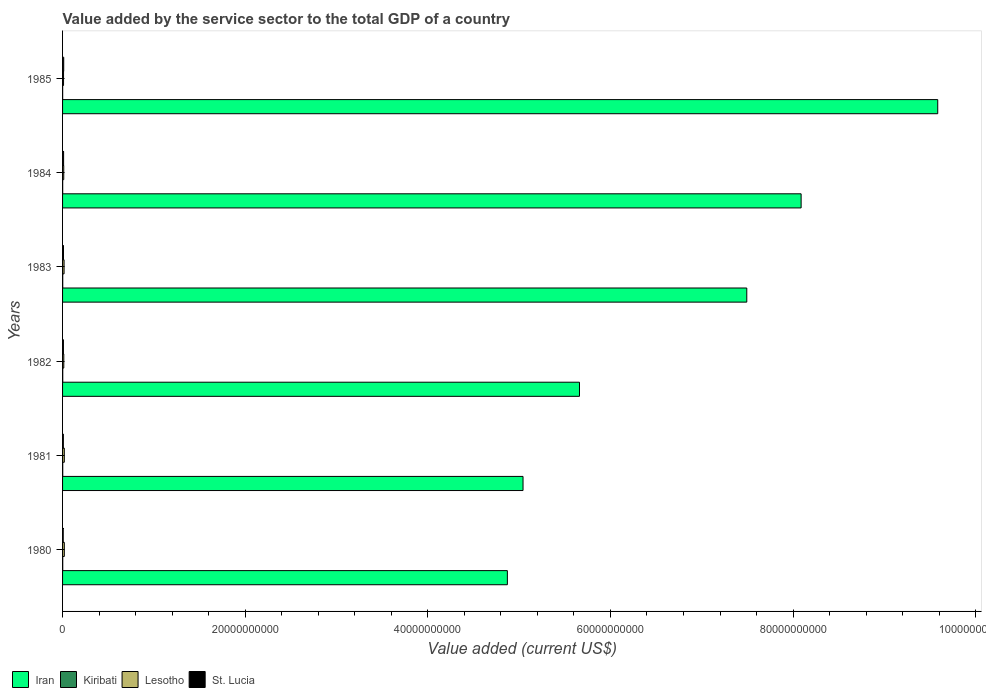How many different coloured bars are there?
Your answer should be very brief. 4. Are the number of bars per tick equal to the number of legend labels?
Offer a terse response. Yes. Are the number of bars on each tick of the Y-axis equal?
Your answer should be compact. Yes. How many bars are there on the 6th tick from the top?
Your answer should be compact. 4. How many bars are there on the 1st tick from the bottom?
Give a very brief answer. 4. What is the value added by the service sector to the total GDP in Kiribati in 1984?
Your answer should be compact. 1.28e+07. Across all years, what is the maximum value added by the service sector to the total GDP in Iran?
Offer a very short reply. 9.58e+1. Across all years, what is the minimum value added by the service sector to the total GDP in Iran?
Ensure brevity in your answer.  4.87e+1. What is the total value added by the service sector to the total GDP in Lesotho in the graph?
Ensure brevity in your answer.  9.23e+08. What is the difference between the value added by the service sector to the total GDP in Kiribati in 1982 and that in 1983?
Provide a succinct answer. 8.66e+05. What is the difference between the value added by the service sector to the total GDP in Lesotho in 1985 and the value added by the service sector to the total GDP in Iran in 1982?
Your answer should be very brief. -5.65e+1. What is the average value added by the service sector to the total GDP in Kiribati per year?
Offer a very short reply. 1.65e+07. In the year 1983, what is the difference between the value added by the service sector to the total GDP in Lesotho and value added by the service sector to the total GDP in Iran?
Provide a succinct answer. -7.48e+1. What is the ratio of the value added by the service sector to the total GDP in St. Lucia in 1981 to that in 1983?
Provide a short and direct response. 0.83. Is the difference between the value added by the service sector to the total GDP in Lesotho in 1982 and 1984 greater than the difference between the value added by the service sector to the total GDP in Iran in 1982 and 1984?
Your answer should be compact. Yes. What is the difference between the highest and the second highest value added by the service sector to the total GDP in Lesotho?
Offer a terse response. 7.68e+05. What is the difference between the highest and the lowest value added by the service sector to the total GDP in Iran?
Provide a short and direct response. 4.71e+1. In how many years, is the value added by the service sector to the total GDP in Kiribati greater than the average value added by the service sector to the total GDP in Kiribati taken over all years?
Give a very brief answer. 4. Is it the case that in every year, the sum of the value added by the service sector to the total GDP in Kiribati and value added by the service sector to the total GDP in Lesotho is greater than the sum of value added by the service sector to the total GDP in Iran and value added by the service sector to the total GDP in St. Lucia?
Offer a very short reply. No. What does the 2nd bar from the top in 1981 represents?
Your answer should be compact. Lesotho. What does the 2nd bar from the bottom in 1984 represents?
Your response must be concise. Kiribati. Is it the case that in every year, the sum of the value added by the service sector to the total GDP in Kiribati and value added by the service sector to the total GDP in Iran is greater than the value added by the service sector to the total GDP in St. Lucia?
Your response must be concise. Yes. How many bars are there?
Your answer should be compact. 24. Are all the bars in the graph horizontal?
Your answer should be compact. Yes. Are the values on the major ticks of X-axis written in scientific E-notation?
Provide a succinct answer. No. Does the graph contain grids?
Provide a succinct answer. No. How many legend labels are there?
Your response must be concise. 4. What is the title of the graph?
Keep it short and to the point. Value added by the service sector to the total GDP of a country. What is the label or title of the X-axis?
Give a very brief answer. Value added (current US$). What is the Value added (current US$) in Iran in 1980?
Keep it short and to the point. 4.87e+1. What is the Value added (current US$) of Kiribati in 1980?
Make the answer very short. 1.87e+07. What is the Value added (current US$) in Lesotho in 1980?
Make the answer very short. 1.92e+08. What is the Value added (current US$) of St. Lucia in 1980?
Offer a very short reply. 7.13e+07. What is the Value added (current US$) in Iran in 1981?
Your answer should be compact. 5.04e+1. What is the Value added (current US$) in Kiribati in 1981?
Ensure brevity in your answer.  1.85e+07. What is the Value added (current US$) of Lesotho in 1981?
Your answer should be very brief. 1.91e+08. What is the Value added (current US$) in St. Lucia in 1981?
Give a very brief answer. 8.51e+07. What is the Value added (current US$) of Iran in 1982?
Keep it short and to the point. 5.66e+1. What is the Value added (current US$) of Kiribati in 1982?
Give a very brief answer. 1.95e+07. What is the Value added (current US$) in Lesotho in 1982?
Ensure brevity in your answer.  1.36e+08. What is the Value added (current US$) of St. Lucia in 1982?
Keep it short and to the point. 9.37e+07. What is the Value added (current US$) in Iran in 1983?
Your answer should be compact. 7.49e+1. What is the Value added (current US$) in Kiribati in 1983?
Provide a succinct answer. 1.86e+07. What is the Value added (current US$) of Lesotho in 1983?
Your answer should be very brief. 1.66e+08. What is the Value added (current US$) of St. Lucia in 1983?
Keep it short and to the point. 1.03e+08. What is the Value added (current US$) of Iran in 1984?
Offer a very short reply. 8.09e+1. What is the Value added (current US$) in Kiribati in 1984?
Your answer should be compact. 1.28e+07. What is the Value added (current US$) of Lesotho in 1984?
Make the answer very short. 1.30e+08. What is the Value added (current US$) in St. Lucia in 1984?
Offer a terse response. 1.14e+08. What is the Value added (current US$) in Iran in 1985?
Make the answer very short. 9.58e+1. What is the Value added (current US$) in Kiribati in 1985?
Provide a short and direct response. 1.07e+07. What is the Value added (current US$) of Lesotho in 1985?
Offer a very short reply. 1.07e+08. What is the Value added (current US$) of St. Lucia in 1985?
Your answer should be very brief. 1.26e+08. Across all years, what is the maximum Value added (current US$) of Iran?
Make the answer very short. 9.58e+1. Across all years, what is the maximum Value added (current US$) in Kiribati?
Ensure brevity in your answer.  1.95e+07. Across all years, what is the maximum Value added (current US$) in Lesotho?
Make the answer very short. 1.92e+08. Across all years, what is the maximum Value added (current US$) of St. Lucia?
Offer a terse response. 1.26e+08. Across all years, what is the minimum Value added (current US$) in Iran?
Give a very brief answer. 4.87e+1. Across all years, what is the minimum Value added (current US$) of Kiribati?
Make the answer very short. 1.07e+07. Across all years, what is the minimum Value added (current US$) in Lesotho?
Keep it short and to the point. 1.07e+08. Across all years, what is the minimum Value added (current US$) in St. Lucia?
Provide a succinct answer. 7.13e+07. What is the total Value added (current US$) in Iran in the graph?
Offer a very short reply. 4.07e+11. What is the total Value added (current US$) of Kiribati in the graph?
Provide a short and direct response. 9.89e+07. What is the total Value added (current US$) of Lesotho in the graph?
Give a very brief answer. 9.23e+08. What is the total Value added (current US$) of St. Lucia in the graph?
Offer a very short reply. 5.93e+08. What is the difference between the Value added (current US$) of Iran in 1980 and that in 1981?
Your answer should be very brief. -1.72e+09. What is the difference between the Value added (current US$) of Kiribati in 1980 and that in 1981?
Your response must be concise. 1.97e+05. What is the difference between the Value added (current US$) of Lesotho in 1980 and that in 1981?
Ensure brevity in your answer.  7.68e+05. What is the difference between the Value added (current US$) in St. Lucia in 1980 and that in 1981?
Provide a succinct answer. -1.37e+07. What is the difference between the Value added (current US$) in Iran in 1980 and that in 1982?
Your answer should be very brief. -7.90e+09. What is the difference between the Value added (current US$) in Kiribati in 1980 and that in 1982?
Offer a terse response. -7.15e+05. What is the difference between the Value added (current US$) of Lesotho in 1980 and that in 1982?
Keep it short and to the point. 5.66e+07. What is the difference between the Value added (current US$) in St. Lucia in 1980 and that in 1982?
Your answer should be compact. -2.24e+07. What is the difference between the Value added (current US$) in Iran in 1980 and that in 1983?
Make the answer very short. -2.62e+1. What is the difference between the Value added (current US$) of Kiribati in 1980 and that in 1983?
Your answer should be very brief. 1.51e+05. What is the difference between the Value added (current US$) of Lesotho in 1980 and that in 1983?
Your response must be concise. 2.58e+07. What is the difference between the Value added (current US$) in St. Lucia in 1980 and that in 1983?
Your answer should be very brief. -3.17e+07. What is the difference between the Value added (current US$) in Iran in 1980 and that in 1984?
Ensure brevity in your answer.  -3.22e+1. What is the difference between the Value added (current US$) in Kiribati in 1980 and that in 1984?
Give a very brief answer. 5.90e+06. What is the difference between the Value added (current US$) of Lesotho in 1980 and that in 1984?
Your answer should be very brief. 6.21e+07. What is the difference between the Value added (current US$) in St. Lucia in 1980 and that in 1984?
Keep it short and to the point. -4.26e+07. What is the difference between the Value added (current US$) of Iran in 1980 and that in 1985?
Make the answer very short. -4.71e+1. What is the difference between the Value added (current US$) of Kiribati in 1980 and that in 1985?
Provide a succinct answer. 8.03e+06. What is the difference between the Value added (current US$) in Lesotho in 1980 and that in 1985?
Your response must be concise. 8.54e+07. What is the difference between the Value added (current US$) of St. Lucia in 1980 and that in 1985?
Make the answer very short. -5.46e+07. What is the difference between the Value added (current US$) in Iran in 1981 and that in 1982?
Your answer should be very brief. -6.18e+09. What is the difference between the Value added (current US$) in Kiribati in 1981 and that in 1982?
Your answer should be compact. -9.12e+05. What is the difference between the Value added (current US$) of Lesotho in 1981 and that in 1982?
Provide a short and direct response. 5.58e+07. What is the difference between the Value added (current US$) in St. Lucia in 1981 and that in 1982?
Your response must be concise. -8.67e+06. What is the difference between the Value added (current US$) of Iran in 1981 and that in 1983?
Your answer should be very brief. -2.45e+1. What is the difference between the Value added (current US$) of Kiribati in 1981 and that in 1983?
Provide a succinct answer. -4.57e+04. What is the difference between the Value added (current US$) of Lesotho in 1981 and that in 1983?
Provide a short and direct response. 2.50e+07. What is the difference between the Value added (current US$) in St. Lucia in 1981 and that in 1983?
Your response must be concise. -1.80e+07. What is the difference between the Value added (current US$) in Iran in 1981 and that in 1984?
Offer a terse response. -3.05e+1. What is the difference between the Value added (current US$) in Kiribati in 1981 and that in 1984?
Ensure brevity in your answer.  5.70e+06. What is the difference between the Value added (current US$) in Lesotho in 1981 and that in 1984?
Provide a succinct answer. 6.14e+07. What is the difference between the Value added (current US$) in St. Lucia in 1981 and that in 1984?
Your answer should be very brief. -2.89e+07. What is the difference between the Value added (current US$) in Iran in 1981 and that in 1985?
Your response must be concise. -4.54e+1. What is the difference between the Value added (current US$) in Kiribati in 1981 and that in 1985?
Keep it short and to the point. 7.83e+06. What is the difference between the Value added (current US$) in Lesotho in 1981 and that in 1985?
Offer a terse response. 8.46e+07. What is the difference between the Value added (current US$) in St. Lucia in 1981 and that in 1985?
Make the answer very short. -4.09e+07. What is the difference between the Value added (current US$) in Iran in 1982 and that in 1983?
Your response must be concise. -1.83e+1. What is the difference between the Value added (current US$) in Kiribati in 1982 and that in 1983?
Provide a short and direct response. 8.66e+05. What is the difference between the Value added (current US$) in Lesotho in 1982 and that in 1983?
Your answer should be compact. -3.08e+07. What is the difference between the Value added (current US$) of St. Lucia in 1982 and that in 1983?
Offer a very short reply. -9.30e+06. What is the difference between the Value added (current US$) of Iran in 1982 and that in 1984?
Your response must be concise. -2.43e+1. What is the difference between the Value added (current US$) of Kiribati in 1982 and that in 1984?
Provide a short and direct response. 6.61e+06. What is the difference between the Value added (current US$) of Lesotho in 1982 and that in 1984?
Your answer should be compact. 5.53e+06. What is the difference between the Value added (current US$) of St. Lucia in 1982 and that in 1984?
Ensure brevity in your answer.  -2.02e+07. What is the difference between the Value added (current US$) in Iran in 1982 and that in 1985?
Offer a very short reply. -3.92e+1. What is the difference between the Value added (current US$) of Kiribati in 1982 and that in 1985?
Keep it short and to the point. 8.74e+06. What is the difference between the Value added (current US$) in Lesotho in 1982 and that in 1985?
Provide a succinct answer. 2.88e+07. What is the difference between the Value added (current US$) in St. Lucia in 1982 and that in 1985?
Make the answer very short. -3.22e+07. What is the difference between the Value added (current US$) of Iran in 1983 and that in 1984?
Your answer should be compact. -5.95e+09. What is the difference between the Value added (current US$) of Kiribati in 1983 and that in 1984?
Offer a very short reply. 5.74e+06. What is the difference between the Value added (current US$) in Lesotho in 1983 and that in 1984?
Make the answer very short. 3.64e+07. What is the difference between the Value added (current US$) in St. Lucia in 1983 and that in 1984?
Your response must be concise. -1.09e+07. What is the difference between the Value added (current US$) of Iran in 1983 and that in 1985?
Your answer should be very brief. -2.09e+1. What is the difference between the Value added (current US$) in Kiribati in 1983 and that in 1985?
Your answer should be very brief. 7.88e+06. What is the difference between the Value added (current US$) of Lesotho in 1983 and that in 1985?
Offer a terse response. 5.96e+07. What is the difference between the Value added (current US$) in St. Lucia in 1983 and that in 1985?
Your response must be concise. -2.29e+07. What is the difference between the Value added (current US$) in Iran in 1984 and that in 1985?
Offer a terse response. -1.50e+1. What is the difference between the Value added (current US$) of Kiribati in 1984 and that in 1985?
Provide a succinct answer. 2.13e+06. What is the difference between the Value added (current US$) of Lesotho in 1984 and that in 1985?
Make the answer very short. 2.33e+07. What is the difference between the Value added (current US$) of St. Lucia in 1984 and that in 1985?
Your response must be concise. -1.20e+07. What is the difference between the Value added (current US$) of Iran in 1980 and the Value added (current US$) of Kiribati in 1981?
Offer a very short reply. 4.87e+1. What is the difference between the Value added (current US$) of Iran in 1980 and the Value added (current US$) of Lesotho in 1981?
Give a very brief answer. 4.85e+1. What is the difference between the Value added (current US$) of Iran in 1980 and the Value added (current US$) of St. Lucia in 1981?
Your answer should be compact. 4.86e+1. What is the difference between the Value added (current US$) of Kiribati in 1980 and the Value added (current US$) of Lesotho in 1981?
Your answer should be compact. -1.73e+08. What is the difference between the Value added (current US$) of Kiribati in 1980 and the Value added (current US$) of St. Lucia in 1981?
Ensure brevity in your answer.  -6.63e+07. What is the difference between the Value added (current US$) in Lesotho in 1980 and the Value added (current US$) in St. Lucia in 1981?
Offer a terse response. 1.07e+08. What is the difference between the Value added (current US$) in Iran in 1980 and the Value added (current US$) in Kiribati in 1982?
Provide a succinct answer. 4.87e+1. What is the difference between the Value added (current US$) in Iran in 1980 and the Value added (current US$) in Lesotho in 1982?
Your answer should be very brief. 4.86e+1. What is the difference between the Value added (current US$) of Iran in 1980 and the Value added (current US$) of St. Lucia in 1982?
Your answer should be compact. 4.86e+1. What is the difference between the Value added (current US$) in Kiribati in 1980 and the Value added (current US$) in Lesotho in 1982?
Your response must be concise. -1.17e+08. What is the difference between the Value added (current US$) of Kiribati in 1980 and the Value added (current US$) of St. Lucia in 1982?
Make the answer very short. -7.50e+07. What is the difference between the Value added (current US$) of Lesotho in 1980 and the Value added (current US$) of St. Lucia in 1982?
Your answer should be very brief. 9.85e+07. What is the difference between the Value added (current US$) in Iran in 1980 and the Value added (current US$) in Kiribati in 1983?
Offer a very short reply. 4.87e+1. What is the difference between the Value added (current US$) in Iran in 1980 and the Value added (current US$) in Lesotho in 1983?
Your response must be concise. 4.85e+1. What is the difference between the Value added (current US$) of Iran in 1980 and the Value added (current US$) of St. Lucia in 1983?
Your answer should be compact. 4.86e+1. What is the difference between the Value added (current US$) of Kiribati in 1980 and the Value added (current US$) of Lesotho in 1983?
Offer a very short reply. -1.48e+08. What is the difference between the Value added (current US$) of Kiribati in 1980 and the Value added (current US$) of St. Lucia in 1983?
Offer a terse response. -8.43e+07. What is the difference between the Value added (current US$) in Lesotho in 1980 and the Value added (current US$) in St. Lucia in 1983?
Provide a short and direct response. 8.92e+07. What is the difference between the Value added (current US$) in Iran in 1980 and the Value added (current US$) in Kiribati in 1984?
Offer a terse response. 4.87e+1. What is the difference between the Value added (current US$) in Iran in 1980 and the Value added (current US$) in Lesotho in 1984?
Keep it short and to the point. 4.86e+1. What is the difference between the Value added (current US$) in Iran in 1980 and the Value added (current US$) in St. Lucia in 1984?
Provide a short and direct response. 4.86e+1. What is the difference between the Value added (current US$) in Kiribati in 1980 and the Value added (current US$) in Lesotho in 1984?
Provide a short and direct response. -1.11e+08. What is the difference between the Value added (current US$) of Kiribati in 1980 and the Value added (current US$) of St. Lucia in 1984?
Your answer should be compact. -9.52e+07. What is the difference between the Value added (current US$) of Lesotho in 1980 and the Value added (current US$) of St. Lucia in 1984?
Your answer should be very brief. 7.82e+07. What is the difference between the Value added (current US$) in Iran in 1980 and the Value added (current US$) in Kiribati in 1985?
Keep it short and to the point. 4.87e+1. What is the difference between the Value added (current US$) in Iran in 1980 and the Value added (current US$) in Lesotho in 1985?
Your response must be concise. 4.86e+1. What is the difference between the Value added (current US$) of Iran in 1980 and the Value added (current US$) of St. Lucia in 1985?
Your response must be concise. 4.86e+1. What is the difference between the Value added (current US$) of Kiribati in 1980 and the Value added (current US$) of Lesotho in 1985?
Offer a very short reply. -8.81e+07. What is the difference between the Value added (current US$) in Kiribati in 1980 and the Value added (current US$) in St. Lucia in 1985?
Give a very brief answer. -1.07e+08. What is the difference between the Value added (current US$) in Lesotho in 1980 and the Value added (current US$) in St. Lucia in 1985?
Your answer should be very brief. 6.62e+07. What is the difference between the Value added (current US$) in Iran in 1981 and the Value added (current US$) in Kiribati in 1982?
Provide a succinct answer. 5.04e+1. What is the difference between the Value added (current US$) in Iran in 1981 and the Value added (current US$) in Lesotho in 1982?
Ensure brevity in your answer.  5.03e+1. What is the difference between the Value added (current US$) in Iran in 1981 and the Value added (current US$) in St. Lucia in 1982?
Give a very brief answer. 5.03e+1. What is the difference between the Value added (current US$) in Kiribati in 1981 and the Value added (current US$) in Lesotho in 1982?
Offer a terse response. -1.17e+08. What is the difference between the Value added (current US$) in Kiribati in 1981 and the Value added (current US$) in St. Lucia in 1982?
Provide a short and direct response. -7.52e+07. What is the difference between the Value added (current US$) of Lesotho in 1981 and the Value added (current US$) of St. Lucia in 1982?
Your answer should be compact. 9.77e+07. What is the difference between the Value added (current US$) in Iran in 1981 and the Value added (current US$) in Kiribati in 1983?
Make the answer very short. 5.04e+1. What is the difference between the Value added (current US$) in Iran in 1981 and the Value added (current US$) in Lesotho in 1983?
Your answer should be very brief. 5.03e+1. What is the difference between the Value added (current US$) in Iran in 1981 and the Value added (current US$) in St. Lucia in 1983?
Provide a short and direct response. 5.03e+1. What is the difference between the Value added (current US$) of Kiribati in 1981 and the Value added (current US$) of Lesotho in 1983?
Give a very brief answer. -1.48e+08. What is the difference between the Value added (current US$) in Kiribati in 1981 and the Value added (current US$) in St. Lucia in 1983?
Your answer should be compact. -8.45e+07. What is the difference between the Value added (current US$) of Lesotho in 1981 and the Value added (current US$) of St. Lucia in 1983?
Ensure brevity in your answer.  8.84e+07. What is the difference between the Value added (current US$) in Iran in 1981 and the Value added (current US$) in Kiribati in 1984?
Your response must be concise. 5.04e+1. What is the difference between the Value added (current US$) in Iran in 1981 and the Value added (current US$) in Lesotho in 1984?
Provide a succinct answer. 5.03e+1. What is the difference between the Value added (current US$) of Iran in 1981 and the Value added (current US$) of St. Lucia in 1984?
Make the answer very short. 5.03e+1. What is the difference between the Value added (current US$) of Kiribati in 1981 and the Value added (current US$) of Lesotho in 1984?
Ensure brevity in your answer.  -1.12e+08. What is the difference between the Value added (current US$) in Kiribati in 1981 and the Value added (current US$) in St. Lucia in 1984?
Ensure brevity in your answer.  -9.54e+07. What is the difference between the Value added (current US$) in Lesotho in 1981 and the Value added (current US$) in St. Lucia in 1984?
Your answer should be very brief. 7.75e+07. What is the difference between the Value added (current US$) in Iran in 1981 and the Value added (current US$) in Kiribati in 1985?
Make the answer very short. 5.04e+1. What is the difference between the Value added (current US$) of Iran in 1981 and the Value added (current US$) of Lesotho in 1985?
Your response must be concise. 5.03e+1. What is the difference between the Value added (current US$) in Iran in 1981 and the Value added (current US$) in St. Lucia in 1985?
Provide a short and direct response. 5.03e+1. What is the difference between the Value added (current US$) in Kiribati in 1981 and the Value added (current US$) in Lesotho in 1985?
Keep it short and to the point. -8.83e+07. What is the difference between the Value added (current US$) in Kiribati in 1981 and the Value added (current US$) in St. Lucia in 1985?
Give a very brief answer. -1.07e+08. What is the difference between the Value added (current US$) of Lesotho in 1981 and the Value added (current US$) of St. Lucia in 1985?
Offer a very short reply. 6.55e+07. What is the difference between the Value added (current US$) in Iran in 1982 and the Value added (current US$) in Kiribati in 1983?
Provide a succinct answer. 5.66e+1. What is the difference between the Value added (current US$) of Iran in 1982 and the Value added (current US$) of Lesotho in 1983?
Your answer should be compact. 5.64e+1. What is the difference between the Value added (current US$) of Iran in 1982 and the Value added (current US$) of St. Lucia in 1983?
Provide a succinct answer. 5.65e+1. What is the difference between the Value added (current US$) in Kiribati in 1982 and the Value added (current US$) in Lesotho in 1983?
Your answer should be very brief. -1.47e+08. What is the difference between the Value added (current US$) in Kiribati in 1982 and the Value added (current US$) in St. Lucia in 1983?
Offer a very short reply. -8.36e+07. What is the difference between the Value added (current US$) of Lesotho in 1982 and the Value added (current US$) of St. Lucia in 1983?
Your answer should be compact. 3.26e+07. What is the difference between the Value added (current US$) of Iran in 1982 and the Value added (current US$) of Kiribati in 1984?
Provide a succinct answer. 5.66e+1. What is the difference between the Value added (current US$) in Iran in 1982 and the Value added (current US$) in Lesotho in 1984?
Your answer should be compact. 5.65e+1. What is the difference between the Value added (current US$) of Iran in 1982 and the Value added (current US$) of St. Lucia in 1984?
Your response must be concise. 5.65e+1. What is the difference between the Value added (current US$) of Kiribati in 1982 and the Value added (current US$) of Lesotho in 1984?
Provide a short and direct response. -1.11e+08. What is the difference between the Value added (current US$) of Kiribati in 1982 and the Value added (current US$) of St. Lucia in 1984?
Provide a succinct answer. -9.45e+07. What is the difference between the Value added (current US$) of Lesotho in 1982 and the Value added (current US$) of St. Lucia in 1984?
Your answer should be compact. 2.16e+07. What is the difference between the Value added (current US$) in Iran in 1982 and the Value added (current US$) in Kiribati in 1985?
Your response must be concise. 5.66e+1. What is the difference between the Value added (current US$) of Iran in 1982 and the Value added (current US$) of Lesotho in 1985?
Keep it short and to the point. 5.65e+1. What is the difference between the Value added (current US$) of Iran in 1982 and the Value added (current US$) of St. Lucia in 1985?
Offer a very short reply. 5.65e+1. What is the difference between the Value added (current US$) in Kiribati in 1982 and the Value added (current US$) in Lesotho in 1985?
Your response must be concise. -8.74e+07. What is the difference between the Value added (current US$) of Kiribati in 1982 and the Value added (current US$) of St. Lucia in 1985?
Provide a short and direct response. -1.07e+08. What is the difference between the Value added (current US$) in Lesotho in 1982 and the Value added (current US$) in St. Lucia in 1985?
Provide a short and direct response. 9.62e+06. What is the difference between the Value added (current US$) in Iran in 1983 and the Value added (current US$) in Kiribati in 1984?
Give a very brief answer. 7.49e+1. What is the difference between the Value added (current US$) of Iran in 1983 and the Value added (current US$) of Lesotho in 1984?
Offer a terse response. 7.48e+1. What is the difference between the Value added (current US$) in Iran in 1983 and the Value added (current US$) in St. Lucia in 1984?
Offer a terse response. 7.48e+1. What is the difference between the Value added (current US$) of Kiribati in 1983 and the Value added (current US$) of Lesotho in 1984?
Provide a short and direct response. -1.11e+08. What is the difference between the Value added (current US$) of Kiribati in 1983 and the Value added (current US$) of St. Lucia in 1984?
Give a very brief answer. -9.54e+07. What is the difference between the Value added (current US$) of Lesotho in 1983 and the Value added (current US$) of St. Lucia in 1984?
Ensure brevity in your answer.  5.25e+07. What is the difference between the Value added (current US$) in Iran in 1983 and the Value added (current US$) in Kiribati in 1985?
Offer a very short reply. 7.49e+1. What is the difference between the Value added (current US$) of Iran in 1983 and the Value added (current US$) of Lesotho in 1985?
Ensure brevity in your answer.  7.48e+1. What is the difference between the Value added (current US$) of Iran in 1983 and the Value added (current US$) of St. Lucia in 1985?
Your response must be concise. 7.48e+1. What is the difference between the Value added (current US$) of Kiribati in 1983 and the Value added (current US$) of Lesotho in 1985?
Ensure brevity in your answer.  -8.82e+07. What is the difference between the Value added (current US$) of Kiribati in 1983 and the Value added (current US$) of St. Lucia in 1985?
Your answer should be very brief. -1.07e+08. What is the difference between the Value added (current US$) of Lesotho in 1983 and the Value added (current US$) of St. Lucia in 1985?
Your answer should be very brief. 4.05e+07. What is the difference between the Value added (current US$) in Iran in 1984 and the Value added (current US$) in Kiribati in 1985?
Provide a succinct answer. 8.09e+1. What is the difference between the Value added (current US$) of Iran in 1984 and the Value added (current US$) of Lesotho in 1985?
Your answer should be very brief. 8.08e+1. What is the difference between the Value added (current US$) in Iran in 1984 and the Value added (current US$) in St. Lucia in 1985?
Ensure brevity in your answer.  8.08e+1. What is the difference between the Value added (current US$) in Kiribati in 1984 and the Value added (current US$) in Lesotho in 1985?
Offer a very short reply. -9.40e+07. What is the difference between the Value added (current US$) in Kiribati in 1984 and the Value added (current US$) in St. Lucia in 1985?
Offer a terse response. -1.13e+08. What is the difference between the Value added (current US$) in Lesotho in 1984 and the Value added (current US$) in St. Lucia in 1985?
Provide a succinct answer. 4.09e+06. What is the average Value added (current US$) of Iran per year?
Your answer should be compact. 6.79e+1. What is the average Value added (current US$) of Kiribati per year?
Provide a succinct answer. 1.65e+07. What is the average Value added (current US$) of Lesotho per year?
Provide a succinct answer. 1.54e+08. What is the average Value added (current US$) in St. Lucia per year?
Ensure brevity in your answer.  9.89e+07. In the year 1980, what is the difference between the Value added (current US$) of Iran and Value added (current US$) of Kiribati?
Provide a succinct answer. 4.87e+1. In the year 1980, what is the difference between the Value added (current US$) in Iran and Value added (current US$) in Lesotho?
Your response must be concise. 4.85e+1. In the year 1980, what is the difference between the Value added (current US$) of Iran and Value added (current US$) of St. Lucia?
Make the answer very short. 4.86e+1. In the year 1980, what is the difference between the Value added (current US$) of Kiribati and Value added (current US$) of Lesotho?
Your response must be concise. -1.73e+08. In the year 1980, what is the difference between the Value added (current US$) of Kiribati and Value added (current US$) of St. Lucia?
Keep it short and to the point. -5.26e+07. In the year 1980, what is the difference between the Value added (current US$) in Lesotho and Value added (current US$) in St. Lucia?
Offer a very short reply. 1.21e+08. In the year 1981, what is the difference between the Value added (current US$) in Iran and Value added (current US$) in Kiribati?
Provide a succinct answer. 5.04e+1. In the year 1981, what is the difference between the Value added (current US$) in Iran and Value added (current US$) in Lesotho?
Your answer should be very brief. 5.02e+1. In the year 1981, what is the difference between the Value added (current US$) in Iran and Value added (current US$) in St. Lucia?
Your response must be concise. 5.03e+1. In the year 1981, what is the difference between the Value added (current US$) of Kiribati and Value added (current US$) of Lesotho?
Provide a succinct answer. -1.73e+08. In the year 1981, what is the difference between the Value added (current US$) in Kiribati and Value added (current US$) in St. Lucia?
Ensure brevity in your answer.  -6.65e+07. In the year 1981, what is the difference between the Value added (current US$) of Lesotho and Value added (current US$) of St. Lucia?
Give a very brief answer. 1.06e+08. In the year 1982, what is the difference between the Value added (current US$) of Iran and Value added (current US$) of Kiribati?
Offer a terse response. 5.66e+1. In the year 1982, what is the difference between the Value added (current US$) of Iran and Value added (current US$) of Lesotho?
Your answer should be compact. 5.65e+1. In the year 1982, what is the difference between the Value added (current US$) in Iran and Value added (current US$) in St. Lucia?
Make the answer very short. 5.65e+1. In the year 1982, what is the difference between the Value added (current US$) of Kiribati and Value added (current US$) of Lesotho?
Your answer should be compact. -1.16e+08. In the year 1982, what is the difference between the Value added (current US$) of Kiribati and Value added (current US$) of St. Lucia?
Provide a succinct answer. -7.43e+07. In the year 1982, what is the difference between the Value added (current US$) of Lesotho and Value added (current US$) of St. Lucia?
Ensure brevity in your answer.  4.19e+07. In the year 1983, what is the difference between the Value added (current US$) of Iran and Value added (current US$) of Kiribati?
Your answer should be compact. 7.49e+1. In the year 1983, what is the difference between the Value added (current US$) of Iran and Value added (current US$) of Lesotho?
Give a very brief answer. 7.48e+1. In the year 1983, what is the difference between the Value added (current US$) of Iran and Value added (current US$) of St. Lucia?
Offer a terse response. 7.48e+1. In the year 1983, what is the difference between the Value added (current US$) of Kiribati and Value added (current US$) of Lesotho?
Your answer should be very brief. -1.48e+08. In the year 1983, what is the difference between the Value added (current US$) in Kiribati and Value added (current US$) in St. Lucia?
Your answer should be very brief. -8.44e+07. In the year 1983, what is the difference between the Value added (current US$) of Lesotho and Value added (current US$) of St. Lucia?
Provide a short and direct response. 6.34e+07. In the year 1984, what is the difference between the Value added (current US$) in Iran and Value added (current US$) in Kiribati?
Your answer should be compact. 8.09e+1. In the year 1984, what is the difference between the Value added (current US$) in Iran and Value added (current US$) in Lesotho?
Ensure brevity in your answer.  8.08e+1. In the year 1984, what is the difference between the Value added (current US$) of Iran and Value added (current US$) of St. Lucia?
Your answer should be very brief. 8.08e+1. In the year 1984, what is the difference between the Value added (current US$) in Kiribati and Value added (current US$) in Lesotho?
Ensure brevity in your answer.  -1.17e+08. In the year 1984, what is the difference between the Value added (current US$) in Kiribati and Value added (current US$) in St. Lucia?
Offer a terse response. -1.01e+08. In the year 1984, what is the difference between the Value added (current US$) of Lesotho and Value added (current US$) of St. Lucia?
Your answer should be very brief. 1.61e+07. In the year 1985, what is the difference between the Value added (current US$) of Iran and Value added (current US$) of Kiribati?
Provide a succinct answer. 9.58e+1. In the year 1985, what is the difference between the Value added (current US$) in Iran and Value added (current US$) in Lesotho?
Your answer should be very brief. 9.57e+1. In the year 1985, what is the difference between the Value added (current US$) of Iran and Value added (current US$) of St. Lucia?
Offer a terse response. 9.57e+1. In the year 1985, what is the difference between the Value added (current US$) of Kiribati and Value added (current US$) of Lesotho?
Give a very brief answer. -9.61e+07. In the year 1985, what is the difference between the Value added (current US$) in Kiribati and Value added (current US$) in St. Lucia?
Provide a succinct answer. -1.15e+08. In the year 1985, what is the difference between the Value added (current US$) of Lesotho and Value added (current US$) of St. Lucia?
Your answer should be compact. -1.92e+07. What is the ratio of the Value added (current US$) of Kiribati in 1980 to that in 1981?
Offer a terse response. 1.01. What is the ratio of the Value added (current US$) in St. Lucia in 1980 to that in 1981?
Your answer should be very brief. 0.84. What is the ratio of the Value added (current US$) of Iran in 1980 to that in 1982?
Your answer should be very brief. 0.86. What is the ratio of the Value added (current US$) of Kiribati in 1980 to that in 1982?
Provide a succinct answer. 0.96. What is the ratio of the Value added (current US$) of Lesotho in 1980 to that in 1982?
Your answer should be compact. 1.42. What is the ratio of the Value added (current US$) in St. Lucia in 1980 to that in 1982?
Offer a terse response. 0.76. What is the ratio of the Value added (current US$) in Iran in 1980 to that in 1983?
Offer a terse response. 0.65. What is the ratio of the Value added (current US$) in Kiribati in 1980 to that in 1983?
Make the answer very short. 1.01. What is the ratio of the Value added (current US$) of Lesotho in 1980 to that in 1983?
Make the answer very short. 1.15. What is the ratio of the Value added (current US$) in St. Lucia in 1980 to that in 1983?
Offer a very short reply. 0.69. What is the ratio of the Value added (current US$) of Iran in 1980 to that in 1984?
Give a very brief answer. 0.6. What is the ratio of the Value added (current US$) in Kiribati in 1980 to that in 1984?
Provide a succinct answer. 1.46. What is the ratio of the Value added (current US$) of Lesotho in 1980 to that in 1984?
Provide a short and direct response. 1.48. What is the ratio of the Value added (current US$) of St. Lucia in 1980 to that in 1984?
Offer a very short reply. 0.63. What is the ratio of the Value added (current US$) of Iran in 1980 to that in 1985?
Offer a terse response. 0.51. What is the ratio of the Value added (current US$) of Kiribati in 1980 to that in 1985?
Offer a terse response. 1.75. What is the ratio of the Value added (current US$) in Lesotho in 1980 to that in 1985?
Provide a succinct answer. 1.8. What is the ratio of the Value added (current US$) in St. Lucia in 1980 to that in 1985?
Offer a very short reply. 0.57. What is the ratio of the Value added (current US$) of Iran in 1981 to that in 1982?
Offer a very short reply. 0.89. What is the ratio of the Value added (current US$) in Kiribati in 1981 to that in 1982?
Ensure brevity in your answer.  0.95. What is the ratio of the Value added (current US$) in Lesotho in 1981 to that in 1982?
Offer a very short reply. 1.41. What is the ratio of the Value added (current US$) in St. Lucia in 1981 to that in 1982?
Provide a short and direct response. 0.91. What is the ratio of the Value added (current US$) in Iran in 1981 to that in 1983?
Your answer should be compact. 0.67. What is the ratio of the Value added (current US$) in Kiribati in 1981 to that in 1983?
Give a very brief answer. 1. What is the ratio of the Value added (current US$) of Lesotho in 1981 to that in 1983?
Provide a short and direct response. 1.15. What is the ratio of the Value added (current US$) in St. Lucia in 1981 to that in 1983?
Your answer should be very brief. 0.83. What is the ratio of the Value added (current US$) in Iran in 1981 to that in 1984?
Offer a terse response. 0.62. What is the ratio of the Value added (current US$) of Kiribati in 1981 to that in 1984?
Your answer should be very brief. 1.44. What is the ratio of the Value added (current US$) in Lesotho in 1981 to that in 1984?
Your response must be concise. 1.47. What is the ratio of the Value added (current US$) in St. Lucia in 1981 to that in 1984?
Provide a short and direct response. 0.75. What is the ratio of the Value added (current US$) of Iran in 1981 to that in 1985?
Keep it short and to the point. 0.53. What is the ratio of the Value added (current US$) of Kiribati in 1981 to that in 1985?
Your response must be concise. 1.73. What is the ratio of the Value added (current US$) in Lesotho in 1981 to that in 1985?
Your response must be concise. 1.79. What is the ratio of the Value added (current US$) in St. Lucia in 1981 to that in 1985?
Keep it short and to the point. 0.68. What is the ratio of the Value added (current US$) of Iran in 1982 to that in 1983?
Make the answer very short. 0.76. What is the ratio of the Value added (current US$) of Kiribati in 1982 to that in 1983?
Your response must be concise. 1.05. What is the ratio of the Value added (current US$) of Lesotho in 1982 to that in 1983?
Your response must be concise. 0.81. What is the ratio of the Value added (current US$) in St. Lucia in 1982 to that in 1983?
Provide a short and direct response. 0.91. What is the ratio of the Value added (current US$) in Iran in 1982 to that in 1984?
Offer a very short reply. 0.7. What is the ratio of the Value added (current US$) of Kiribati in 1982 to that in 1984?
Your answer should be compact. 1.51. What is the ratio of the Value added (current US$) in Lesotho in 1982 to that in 1984?
Give a very brief answer. 1.04. What is the ratio of the Value added (current US$) of St. Lucia in 1982 to that in 1984?
Offer a very short reply. 0.82. What is the ratio of the Value added (current US$) in Iran in 1982 to that in 1985?
Your answer should be compact. 0.59. What is the ratio of the Value added (current US$) of Kiribati in 1982 to that in 1985?
Give a very brief answer. 1.82. What is the ratio of the Value added (current US$) in Lesotho in 1982 to that in 1985?
Your answer should be compact. 1.27. What is the ratio of the Value added (current US$) in St. Lucia in 1982 to that in 1985?
Your answer should be compact. 0.74. What is the ratio of the Value added (current US$) of Iran in 1983 to that in 1984?
Offer a very short reply. 0.93. What is the ratio of the Value added (current US$) of Kiribati in 1983 to that in 1984?
Offer a terse response. 1.45. What is the ratio of the Value added (current US$) in Lesotho in 1983 to that in 1984?
Provide a succinct answer. 1.28. What is the ratio of the Value added (current US$) in St. Lucia in 1983 to that in 1984?
Your response must be concise. 0.9. What is the ratio of the Value added (current US$) of Iran in 1983 to that in 1985?
Your answer should be compact. 0.78. What is the ratio of the Value added (current US$) in Kiribati in 1983 to that in 1985?
Make the answer very short. 1.74. What is the ratio of the Value added (current US$) in Lesotho in 1983 to that in 1985?
Ensure brevity in your answer.  1.56. What is the ratio of the Value added (current US$) in St. Lucia in 1983 to that in 1985?
Offer a terse response. 0.82. What is the ratio of the Value added (current US$) in Iran in 1984 to that in 1985?
Your answer should be very brief. 0.84. What is the ratio of the Value added (current US$) of Kiribati in 1984 to that in 1985?
Ensure brevity in your answer.  1.2. What is the ratio of the Value added (current US$) in Lesotho in 1984 to that in 1985?
Keep it short and to the point. 1.22. What is the ratio of the Value added (current US$) of St. Lucia in 1984 to that in 1985?
Keep it short and to the point. 0.9. What is the difference between the highest and the second highest Value added (current US$) in Iran?
Your answer should be very brief. 1.50e+1. What is the difference between the highest and the second highest Value added (current US$) of Kiribati?
Offer a very short reply. 7.15e+05. What is the difference between the highest and the second highest Value added (current US$) in Lesotho?
Make the answer very short. 7.68e+05. What is the difference between the highest and the second highest Value added (current US$) in St. Lucia?
Your response must be concise. 1.20e+07. What is the difference between the highest and the lowest Value added (current US$) in Iran?
Make the answer very short. 4.71e+1. What is the difference between the highest and the lowest Value added (current US$) in Kiribati?
Your response must be concise. 8.74e+06. What is the difference between the highest and the lowest Value added (current US$) of Lesotho?
Your answer should be very brief. 8.54e+07. What is the difference between the highest and the lowest Value added (current US$) in St. Lucia?
Offer a terse response. 5.46e+07. 